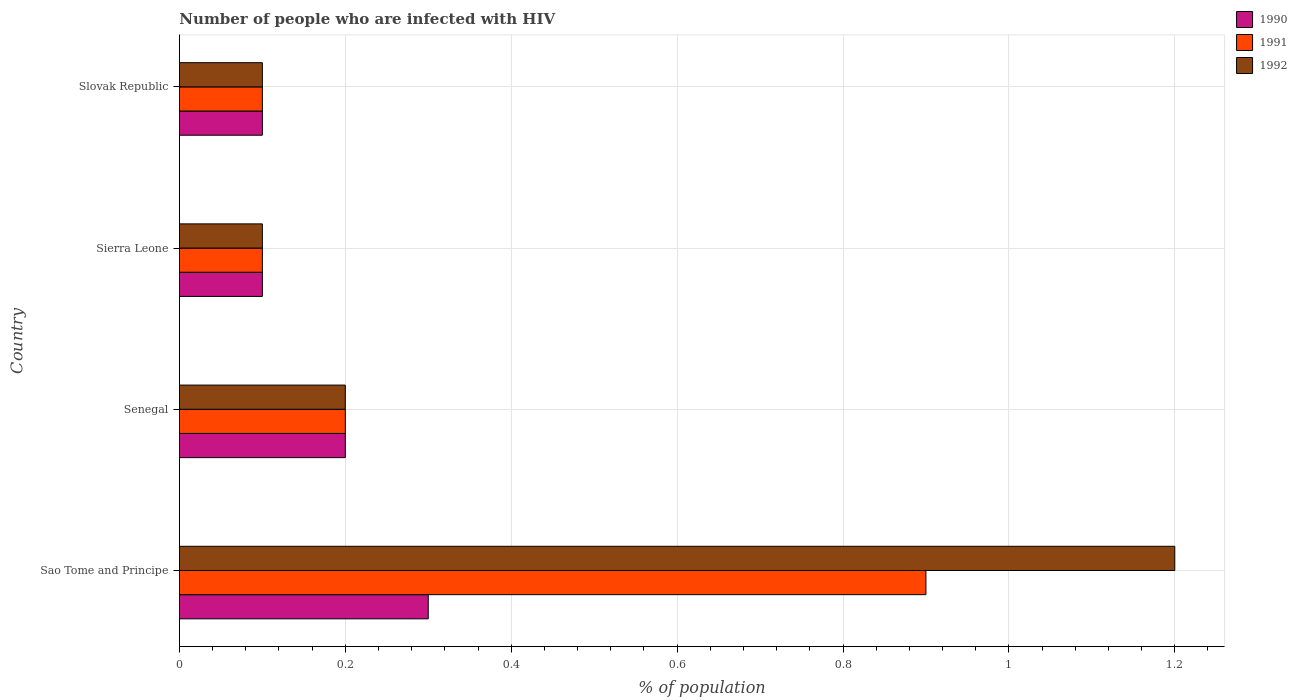How many different coloured bars are there?
Provide a succinct answer. 3. Are the number of bars per tick equal to the number of legend labels?
Your answer should be very brief. Yes. How many bars are there on the 2nd tick from the top?
Give a very brief answer. 3. How many bars are there on the 3rd tick from the bottom?
Offer a terse response. 3. What is the label of the 4th group of bars from the top?
Offer a very short reply. Sao Tome and Principe. What is the percentage of HIV infected population in in 1990 in Slovak Republic?
Provide a short and direct response. 0.1. In which country was the percentage of HIV infected population in in 1990 maximum?
Make the answer very short. Sao Tome and Principe. In which country was the percentage of HIV infected population in in 1992 minimum?
Give a very brief answer. Sierra Leone. What is the total percentage of HIV infected population in in 1992 in the graph?
Your answer should be compact. 1.6. What is the difference between the percentage of HIV infected population in in 1990 in Sierra Leone and that in Slovak Republic?
Offer a terse response. 0. What is the average percentage of HIV infected population in in 1990 per country?
Keep it short and to the point. 0.17. Is the percentage of HIV infected population in in 1992 in Senegal less than that in Slovak Republic?
Ensure brevity in your answer.  No. Is the difference between the percentage of HIV infected population in in 1990 in Sao Tome and Principe and Sierra Leone greater than the difference between the percentage of HIV infected population in in 1991 in Sao Tome and Principe and Sierra Leone?
Ensure brevity in your answer.  No. What is the difference between the highest and the second highest percentage of HIV infected population in in 1991?
Your answer should be compact. 0.7. In how many countries, is the percentage of HIV infected population in in 1992 greater than the average percentage of HIV infected population in in 1992 taken over all countries?
Offer a terse response. 1. What does the 3rd bar from the bottom in Senegal represents?
Keep it short and to the point. 1992. Is it the case that in every country, the sum of the percentage of HIV infected population in in 1992 and percentage of HIV infected population in in 1990 is greater than the percentage of HIV infected population in in 1991?
Make the answer very short. Yes. How many bars are there?
Your response must be concise. 12. Are all the bars in the graph horizontal?
Give a very brief answer. Yes. How many countries are there in the graph?
Give a very brief answer. 4. Where does the legend appear in the graph?
Give a very brief answer. Top right. What is the title of the graph?
Your response must be concise. Number of people who are infected with HIV. Does "1997" appear as one of the legend labels in the graph?
Offer a terse response. No. What is the label or title of the X-axis?
Your answer should be very brief. % of population. What is the label or title of the Y-axis?
Keep it short and to the point. Country. What is the % of population of 1991 in Sao Tome and Principe?
Provide a short and direct response. 0.9. What is the % of population in 1990 in Senegal?
Keep it short and to the point. 0.2. What is the % of population in 1991 in Sierra Leone?
Provide a short and direct response. 0.1. What is the % of population in 1992 in Sierra Leone?
Provide a succinct answer. 0.1. What is the % of population in 1991 in Slovak Republic?
Your answer should be compact. 0.1. What is the % of population in 1992 in Slovak Republic?
Your answer should be very brief. 0.1. Across all countries, what is the maximum % of population of 1992?
Provide a short and direct response. 1.2. Across all countries, what is the minimum % of population of 1990?
Ensure brevity in your answer.  0.1. Across all countries, what is the minimum % of population in 1991?
Your answer should be very brief. 0.1. What is the difference between the % of population of 1990 in Sao Tome and Principe and that in Senegal?
Ensure brevity in your answer.  0.1. What is the difference between the % of population of 1991 in Sao Tome and Principe and that in Senegal?
Make the answer very short. 0.7. What is the difference between the % of population of 1992 in Sao Tome and Principe and that in Sierra Leone?
Offer a very short reply. 1.1. What is the difference between the % of population of 1990 in Sao Tome and Principe and that in Slovak Republic?
Make the answer very short. 0.2. What is the difference between the % of population in 1991 in Sao Tome and Principe and that in Slovak Republic?
Offer a terse response. 0.8. What is the difference between the % of population in 1992 in Sao Tome and Principe and that in Slovak Republic?
Make the answer very short. 1.1. What is the difference between the % of population in 1990 in Senegal and that in Sierra Leone?
Make the answer very short. 0.1. What is the difference between the % of population of 1991 in Senegal and that in Sierra Leone?
Ensure brevity in your answer.  0.1. What is the difference between the % of population of 1990 in Senegal and that in Slovak Republic?
Give a very brief answer. 0.1. What is the difference between the % of population of 1992 in Sierra Leone and that in Slovak Republic?
Keep it short and to the point. 0. What is the difference between the % of population in 1990 in Sao Tome and Principe and the % of population in 1991 in Slovak Republic?
Your answer should be compact. 0.2. What is the difference between the % of population in 1990 in Senegal and the % of population in 1991 in Sierra Leone?
Your answer should be compact. 0.1. What is the difference between the % of population of 1990 in Senegal and the % of population of 1991 in Slovak Republic?
Keep it short and to the point. 0.1. What is the difference between the % of population in 1991 in Senegal and the % of population in 1992 in Slovak Republic?
Your answer should be compact. 0.1. What is the difference between the % of population in 1990 in Sierra Leone and the % of population in 1991 in Slovak Republic?
Offer a very short reply. 0. What is the average % of population of 1990 per country?
Offer a terse response. 0.17. What is the average % of population of 1991 per country?
Your answer should be very brief. 0.33. What is the difference between the % of population of 1990 and % of population of 1992 in Sao Tome and Principe?
Ensure brevity in your answer.  -0.9. What is the difference between the % of population of 1991 and % of population of 1992 in Sao Tome and Principe?
Offer a very short reply. -0.3. What is the difference between the % of population of 1991 and % of population of 1992 in Sierra Leone?
Keep it short and to the point. 0. What is the difference between the % of population of 1990 and % of population of 1991 in Slovak Republic?
Your answer should be very brief. 0. What is the difference between the % of population in 1990 and % of population in 1992 in Slovak Republic?
Provide a succinct answer. 0. What is the difference between the % of population in 1991 and % of population in 1992 in Slovak Republic?
Offer a terse response. 0. What is the ratio of the % of population of 1990 in Sao Tome and Principe to that in Senegal?
Your answer should be very brief. 1.5. What is the ratio of the % of population in 1992 in Sao Tome and Principe to that in Senegal?
Provide a short and direct response. 6. What is the ratio of the % of population in 1991 in Sao Tome and Principe to that in Sierra Leone?
Offer a terse response. 9. What is the ratio of the % of population of 1992 in Senegal to that in Sierra Leone?
Make the answer very short. 2. What is the ratio of the % of population in 1992 in Senegal to that in Slovak Republic?
Give a very brief answer. 2. What is the difference between the highest and the second highest % of population of 1990?
Give a very brief answer. 0.1. What is the difference between the highest and the lowest % of population of 1990?
Your answer should be very brief. 0.2. What is the difference between the highest and the lowest % of population in 1991?
Give a very brief answer. 0.8. 